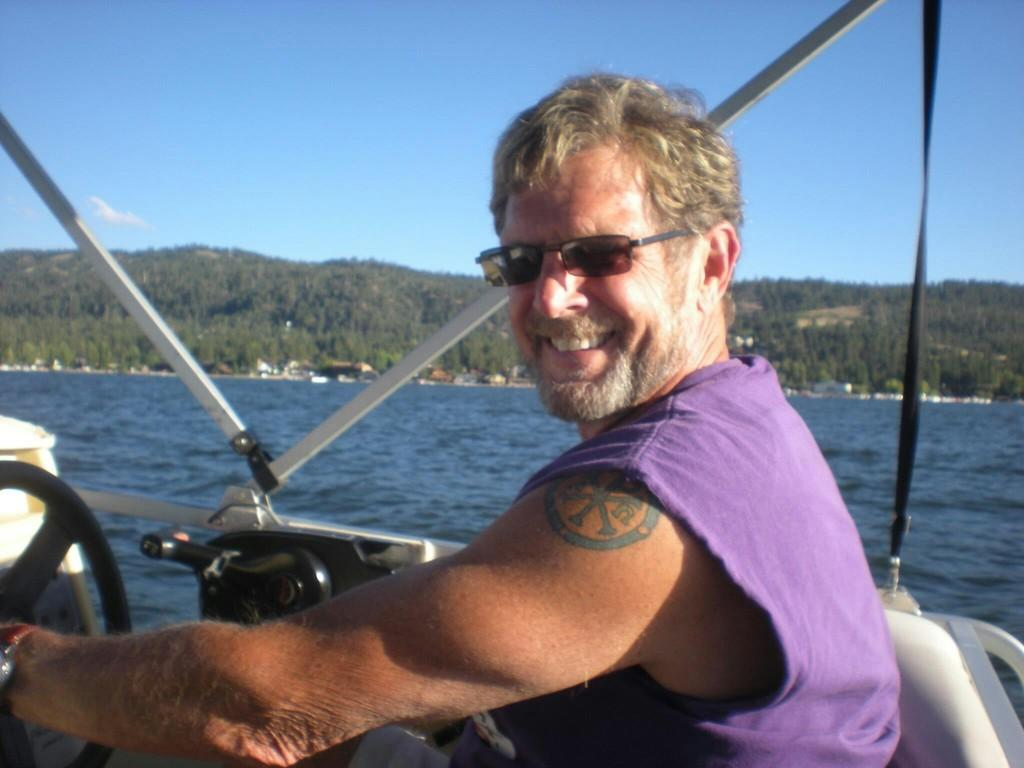What is the main subject of the image? The main subject of the image is a boat. Where is the boat located? The boat is on water. Can you describe the person in the image? The person in the image is smiling. What can be seen in the background of the image? In the background of the image, there are trees, the sky, and some objects. What type of animal can be seen in the image? There is no animal present in the image. How does the person in the image show respect to the weather? The image does not show any indication of the weather or the person's respect towards it. 